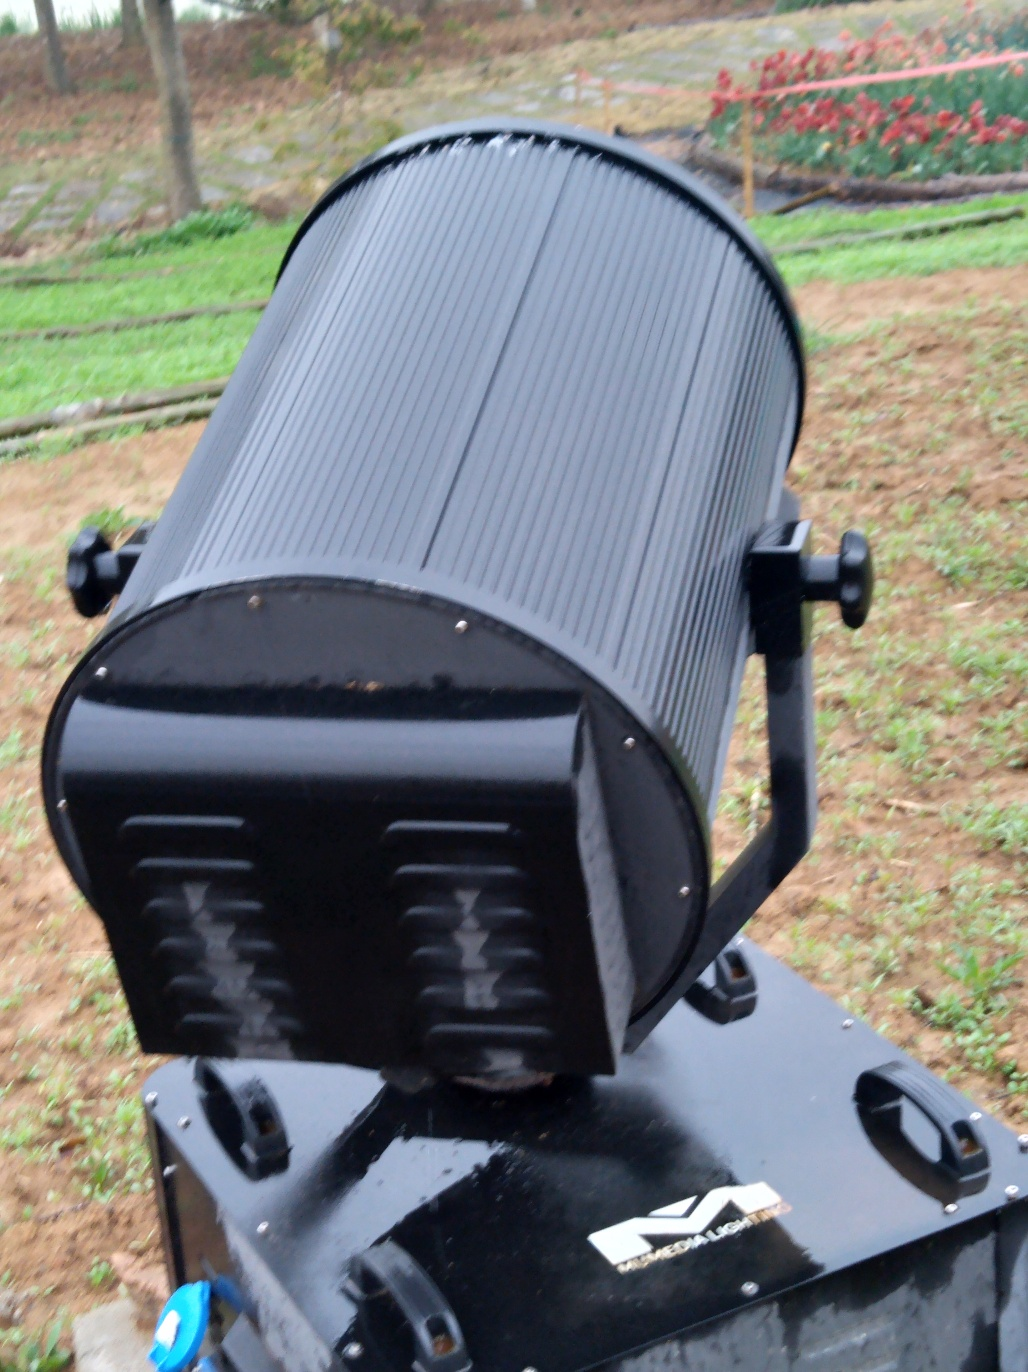What can be said about the texture details? The texture details on the object are fairly well-preserved. You can observe the ridges and subtle variations in the surface of the cylindrical part, as well as the light reflecting off the curved edges, which indicates a rich level of texture detail. 